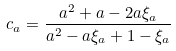<formula> <loc_0><loc_0><loc_500><loc_500>c _ { a } = \frac { a ^ { 2 } + a - 2 a \xi _ { a } } { a ^ { 2 } - a \xi _ { a } + 1 - \xi _ { a } }</formula> 